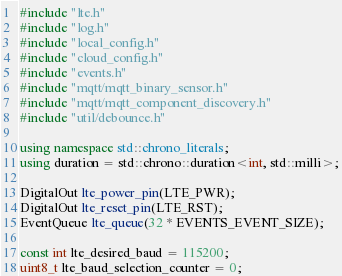Convert code to text. <code><loc_0><loc_0><loc_500><loc_500><_C++_>#include "lte.h"
#include "log.h"
#include "local_config.h"
#include "cloud_config.h"
#include "events.h"
#include "mqtt/mqtt_binary_sensor.h"
#include "mqtt/mqtt_component_discovery.h"
#include "util/debounce.h"

using namespace std::chrono_literals;
using duration = std::chrono::duration<int, std::milli>;

DigitalOut lte_power_pin(LTE_PWR);
DigitalOut lte_reset_pin(LTE_RST);
EventQueue lte_queue(32 * EVENTS_EVENT_SIZE);

const int lte_desired_baud = 115200;
uint8_t lte_baud_selection_counter = 0;</code> 